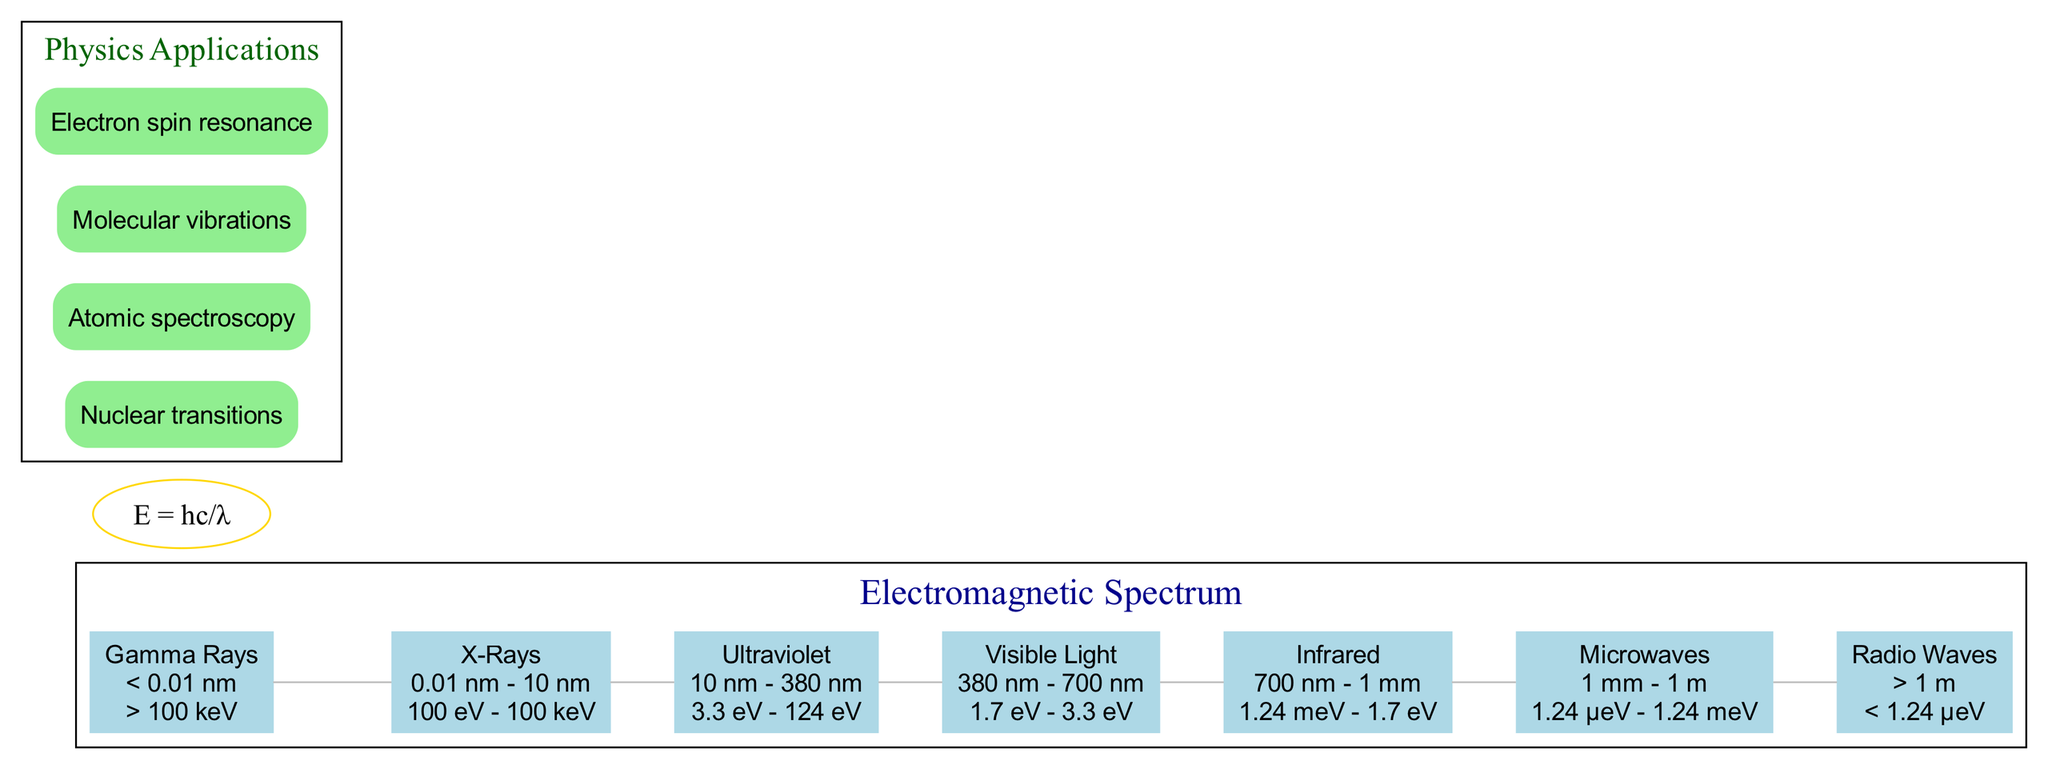What is the wavelength range of X-Rays? The diagram indicates the wavelength range for X-Rays is between 0.01 nm to 10 nm. This specific information is outlined in the node associated with X-Rays.
Answer: 0.01 nm - 10 nm What is the energy level of Gamma Rays? According to the diagram, the energy level of Gamma Rays is greater than 100 keV. This data can be found in the Gamma Rays node and is one of the distinct characteristics of this band.
Answer: > 100 keV Which spectrum band has a wavelength of 380 nm to 700 nm? By examining the nodes in the diagram, it can be seen that the band with a wavelength of 380 nm to 700 nm is Visible Light, as indicated in its corresponding entry.
Answer: Visible Light How many total bands are represented in the diagram? The diagram shows a total of seven spectrum bands (Gamma Rays, X-Rays, Ultraviolet, Visible Light, Infrared, Microwaves, Radio Waves). This can be counted directly from the spectrum bands listed in the visual representation.
Answer: 7 What is the energy range for Ultraviolet? The Ultraviolet band is clearly marked with an energy range of 3.3 eV to 124 eV in the diagram. This energy range is specified explicitly under the Ultraviolet label.
Answer: 3.3 eV - 124 eV Which application is related to Nuclear transitions? Looking at the physics applications section, it is clear that "Nuclear transitions" is explicitly listed as one of the applications, making it straightforward to identify.
Answer: Nuclear transitions What relationship between energy and wavelength is presented in the diagram? The diagram depicts the formula E = hc/λ, which describes the relationship between energy (E) and wavelength (λ). This relationship is crucial in understanding the electromagnetic spectrum's physics.
Answer: E = hc/λ What is the energy range of Infrared wavelengths? Infrared is described in the diagram with an energy range of 1.24 meV to 1.7 eV, as indicated in the node detailing this spectrum band. This information can be directly extracted from the diagram.
Answer: 1.24 meV - 1.7 eV Which band has wavelengths greater than 1 m? The diagram shows that Radio Waves contain wavelengths that are greater than 1 m, according to the details provided in the corresponding band. This is found easily in the node for Radio Waves.
Answer: Radio Waves 